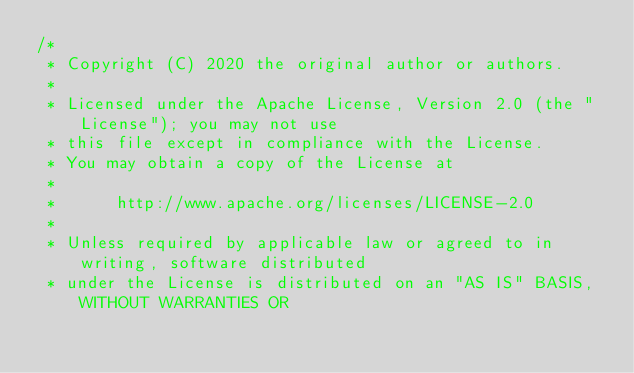Convert code to text. <code><loc_0><loc_0><loc_500><loc_500><_Java_>/*
 * Copyright (C) 2020 the original author or authors.
 *
 * Licensed under the Apache License, Version 2.0 (the "License"); you may not use
 * this file except in compliance with the License.
 * You may obtain a copy of the License at
 *
 *      http://www.apache.org/licenses/LICENSE-2.0
 *
 * Unless required by applicable law or agreed to in writing, software distributed
 * under the License is distributed on an "AS IS" BASIS, WITHOUT WARRANTIES OR</code> 